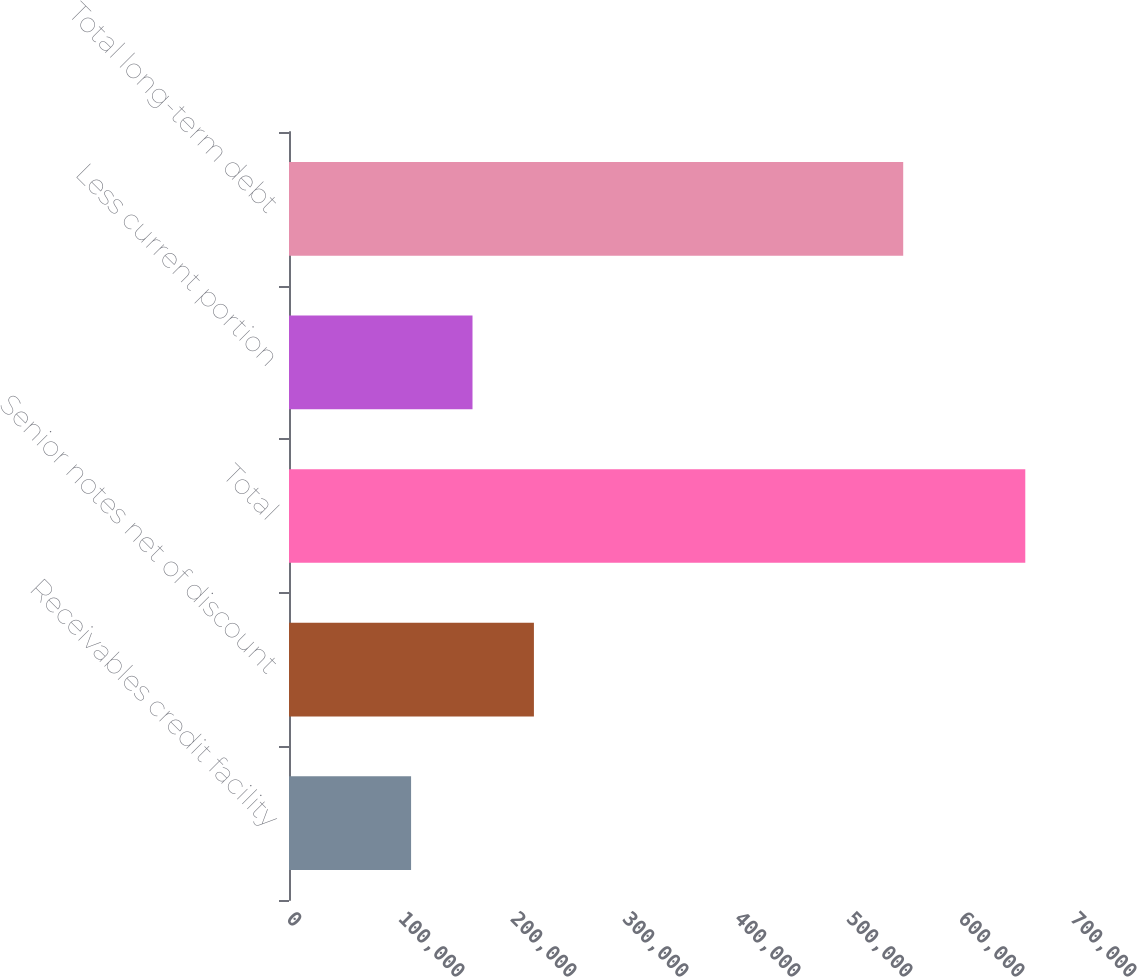<chart> <loc_0><loc_0><loc_500><loc_500><bar_chart><fcel>Receivables credit facility<fcel>Senior notes net of discount<fcel>Total<fcel>Less current portion<fcel>Total long-term debt<nl><fcel>109000<fcel>218680<fcel>657400<fcel>163840<fcel>548400<nl></chart> 